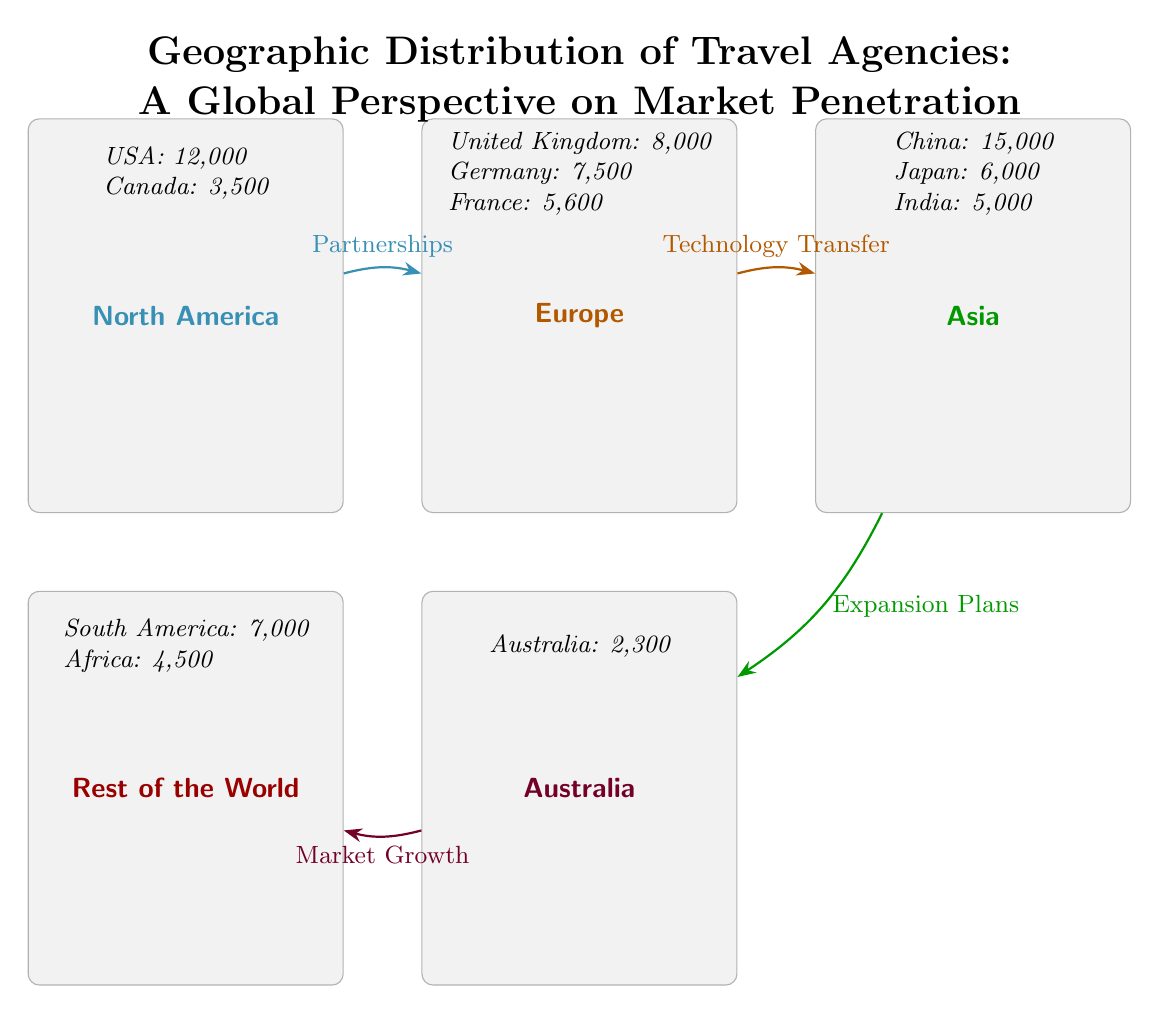What is the total number of travel agencies in North America? The diagram indicates that there are 12,000 travel agencies in the USA and 3,500 in Canada. Adding these together gives a total of 12,000 + 3,500 = 15,500.
Answer: 15,500 Which region has the highest number of travel agencies? The diagram shows that Asia has the highest number of travel agencies, with 15,000 in China, which is the largest single data point in the entire diagram.
Answer: Asia What flow is represented between Europe and Asia? The diagram depicts a connection from Europe to Asia labeled as "Technology Transfer." This indicates the nature of interaction or influence between the two regions.
Answer: Technology Transfer How many travel agencies are listed in Australia? According to the diagram, Australia has 2,300 travel agencies listed under its region.
Answer: 2,300 Which two regions have partnerships as a connection? The diagram illustrates a partnership flow from North America to Europe. This is indicated by the arrow labeled "Partnerships" between the two regions.
Answer: North America and Europe What is the cumulative number of travel agencies in the Rest of the World? The diagram states that in the Rest of the World, there are 7,000 travel agencies in South America and 4,500 in Africa. Summing these gives 7,000 + 4,500 = 11,500.
Answer: 11,500 What is the main focus of the flow from Asia to Australia? The flow connecting Asia to Australia is labeled "Expansion Plans," indicating that the primary aim or activity between these two regions is related to growth and expansion endeavors.
Answer: Expansion Plans Which country in Europe has the fewest travel agencies? Among the countries listed in Europe, France has the smallest number of travel agencies at 5,600.
Answer: France What type of growth is indicated by the flow from Australia to the Rest of the World? The diagram shows that the arrow from Australia to the Rest of the World is marked "Market Growth," which implies that the connection is focused on development and expanding market reach.
Answer: Market Growth 